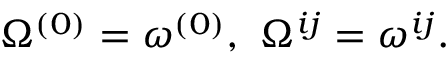Convert formula to latex. <formula><loc_0><loc_0><loc_500><loc_500>\Omega ^ { ( 0 ) } = \omega ^ { ( 0 ) } , \ \Omega ^ { i j } = \omega ^ { i j } .</formula> 